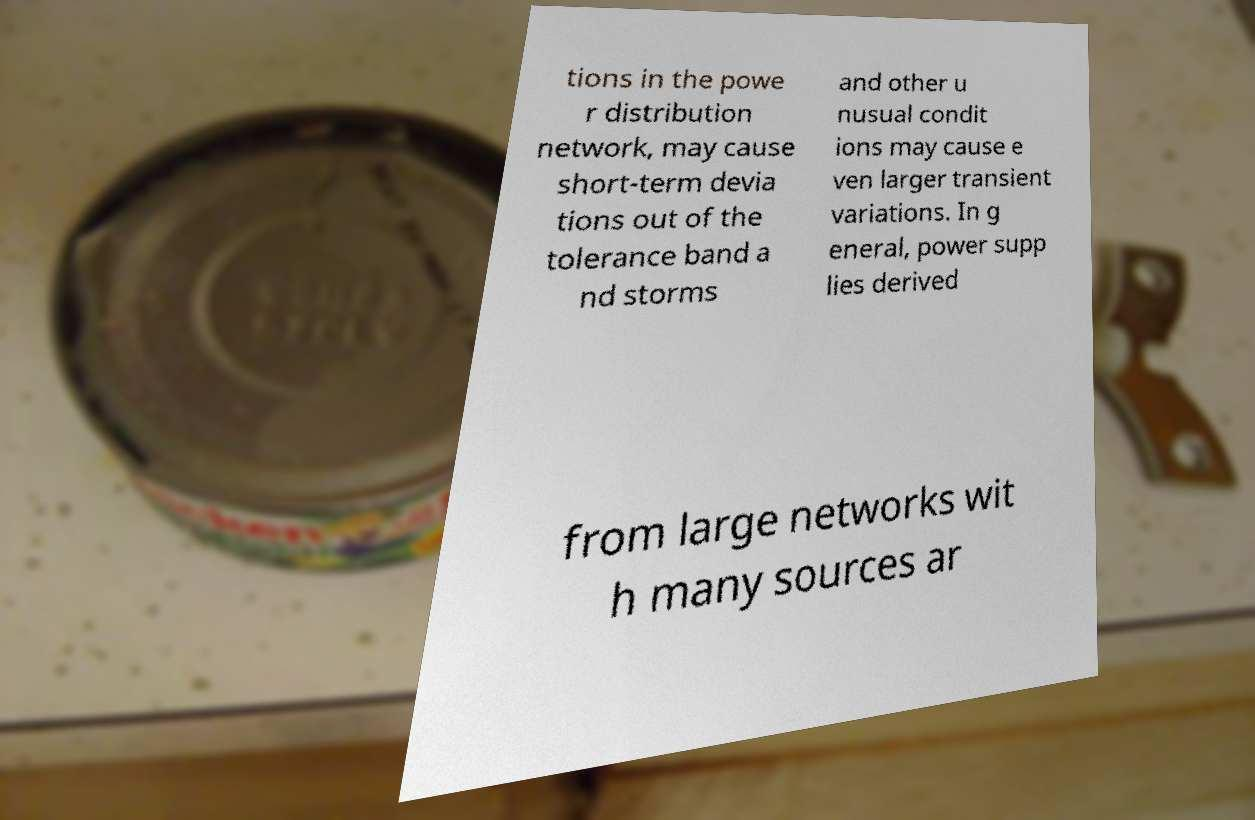There's text embedded in this image that I need extracted. Can you transcribe it verbatim? tions in the powe r distribution network, may cause short-term devia tions out of the tolerance band a nd storms and other u nusual condit ions may cause e ven larger transient variations. In g eneral, power supp lies derived from large networks wit h many sources ar 